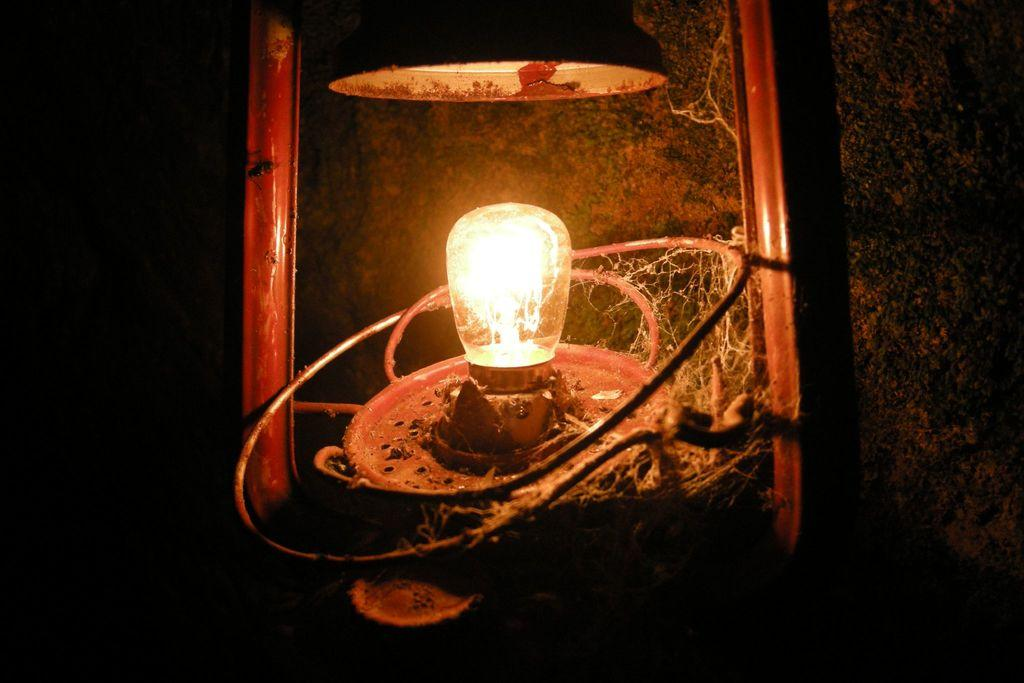What is the main object in the center of the image? There is a lantern in the center of the image. What can be seen in the background of the image? There is a wall in the background of the image. How many houses are visible in the image? There are no houses visible in the image; it only features a lantern and a wall. What type of insect can be seen flying around the lantern in the image? There are no insects present in the image; it only features a lantern and a wall. 